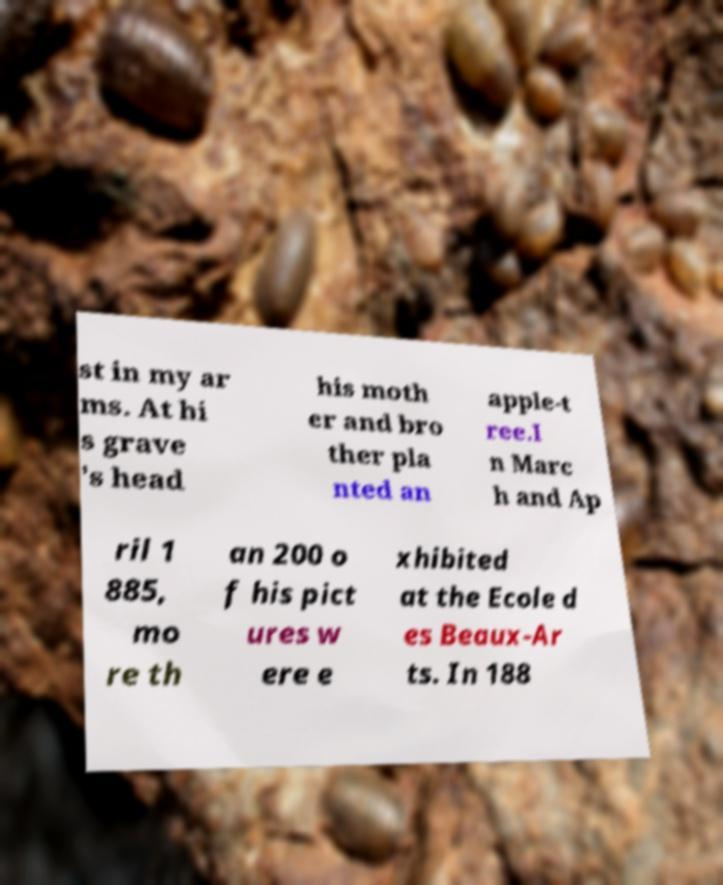Can you read and provide the text displayed in the image?This photo seems to have some interesting text. Can you extract and type it out for me? st in my ar ms. At hi s grave 's head his moth er and bro ther pla nted an apple-t ree.I n Marc h and Ap ril 1 885, mo re th an 200 o f his pict ures w ere e xhibited at the Ecole d es Beaux-Ar ts. In 188 